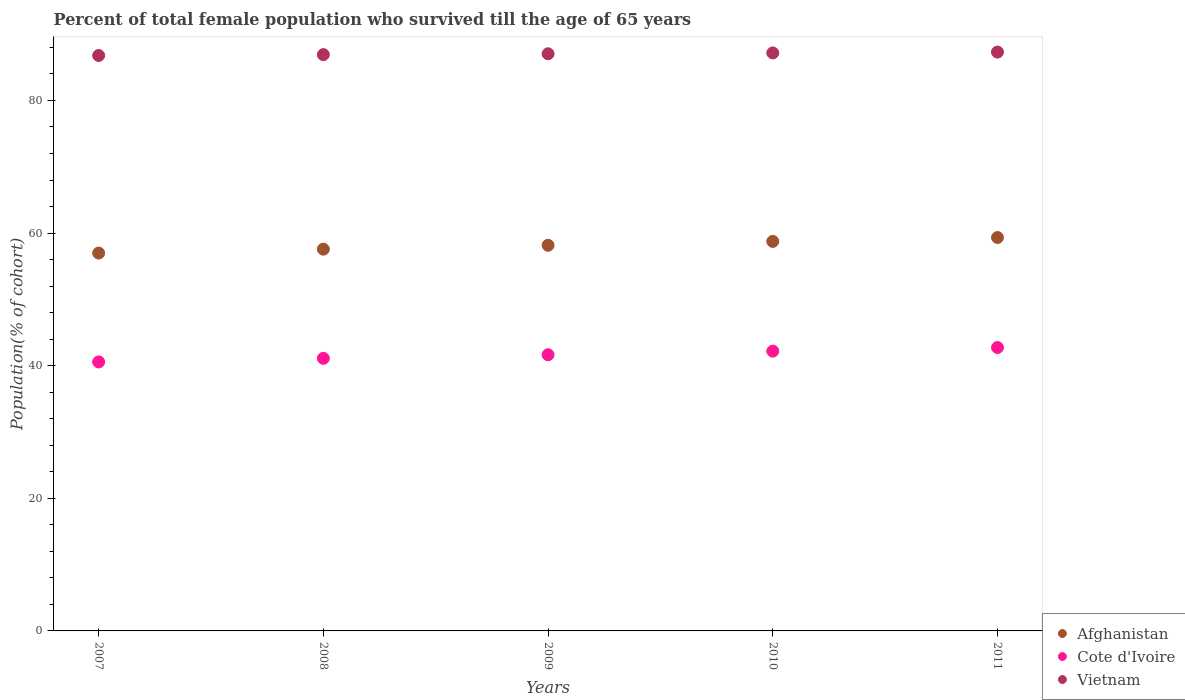How many different coloured dotlines are there?
Keep it short and to the point. 3. What is the percentage of total female population who survived till the age of 65 years in Afghanistan in 2008?
Make the answer very short. 57.57. Across all years, what is the maximum percentage of total female population who survived till the age of 65 years in Cote d'Ivoire?
Your response must be concise. 42.74. Across all years, what is the minimum percentage of total female population who survived till the age of 65 years in Vietnam?
Provide a short and direct response. 86.78. In which year was the percentage of total female population who survived till the age of 65 years in Cote d'Ivoire minimum?
Your response must be concise. 2007. What is the total percentage of total female population who survived till the age of 65 years in Vietnam in the graph?
Your answer should be compact. 435.21. What is the difference between the percentage of total female population who survived till the age of 65 years in Cote d'Ivoire in 2007 and that in 2008?
Ensure brevity in your answer.  -0.54. What is the difference between the percentage of total female population who survived till the age of 65 years in Vietnam in 2010 and the percentage of total female population who survived till the age of 65 years in Afghanistan in 2009?
Ensure brevity in your answer.  29.01. What is the average percentage of total female population who survived till the age of 65 years in Afghanistan per year?
Offer a very short reply. 58.16. In the year 2007, what is the difference between the percentage of total female population who survived till the age of 65 years in Afghanistan and percentage of total female population who survived till the age of 65 years in Cote d'Ivoire?
Keep it short and to the point. 16.42. What is the ratio of the percentage of total female population who survived till the age of 65 years in Afghanistan in 2009 to that in 2010?
Your answer should be compact. 0.99. Is the difference between the percentage of total female population who survived till the age of 65 years in Afghanistan in 2007 and 2011 greater than the difference between the percentage of total female population who survived till the age of 65 years in Cote d'Ivoire in 2007 and 2011?
Offer a very short reply. No. What is the difference between the highest and the second highest percentage of total female population who survived till the age of 65 years in Vietnam?
Offer a very short reply. 0.13. What is the difference between the highest and the lowest percentage of total female population who survived till the age of 65 years in Cote d'Ivoire?
Give a very brief answer. 2.17. Does the percentage of total female population who survived till the age of 65 years in Vietnam monotonically increase over the years?
Your response must be concise. Yes. Is the percentage of total female population who survived till the age of 65 years in Afghanistan strictly greater than the percentage of total female population who survived till the age of 65 years in Cote d'Ivoire over the years?
Keep it short and to the point. Yes. Is the percentage of total female population who survived till the age of 65 years in Afghanistan strictly less than the percentage of total female population who survived till the age of 65 years in Cote d'Ivoire over the years?
Keep it short and to the point. No. How many dotlines are there?
Offer a terse response. 3. What is the difference between two consecutive major ticks on the Y-axis?
Give a very brief answer. 20. Does the graph contain any zero values?
Your answer should be compact. No. Does the graph contain grids?
Provide a succinct answer. No. Where does the legend appear in the graph?
Your answer should be very brief. Bottom right. What is the title of the graph?
Make the answer very short. Percent of total female population who survived till the age of 65 years. What is the label or title of the X-axis?
Your response must be concise. Years. What is the label or title of the Y-axis?
Your response must be concise. Population(% of cohort). What is the Population(% of cohort) of Afghanistan in 2007?
Make the answer very short. 56.99. What is the Population(% of cohort) in Cote d'Ivoire in 2007?
Provide a short and direct response. 40.57. What is the Population(% of cohort) of Vietnam in 2007?
Your answer should be very brief. 86.78. What is the Population(% of cohort) of Afghanistan in 2008?
Your answer should be compact. 57.57. What is the Population(% of cohort) in Cote d'Ivoire in 2008?
Offer a terse response. 41.11. What is the Population(% of cohort) in Vietnam in 2008?
Ensure brevity in your answer.  86.91. What is the Population(% of cohort) of Afghanistan in 2009?
Provide a succinct answer. 58.16. What is the Population(% of cohort) of Cote d'Ivoire in 2009?
Provide a succinct answer. 41.65. What is the Population(% of cohort) in Vietnam in 2009?
Ensure brevity in your answer.  87.04. What is the Population(% of cohort) in Afghanistan in 2010?
Your answer should be very brief. 58.74. What is the Population(% of cohort) of Cote d'Ivoire in 2010?
Provide a short and direct response. 42.2. What is the Population(% of cohort) of Vietnam in 2010?
Your response must be concise. 87.17. What is the Population(% of cohort) in Afghanistan in 2011?
Your answer should be compact. 59.33. What is the Population(% of cohort) in Cote d'Ivoire in 2011?
Provide a short and direct response. 42.74. What is the Population(% of cohort) of Vietnam in 2011?
Make the answer very short. 87.3. Across all years, what is the maximum Population(% of cohort) in Afghanistan?
Offer a very short reply. 59.33. Across all years, what is the maximum Population(% of cohort) of Cote d'Ivoire?
Make the answer very short. 42.74. Across all years, what is the maximum Population(% of cohort) of Vietnam?
Keep it short and to the point. 87.3. Across all years, what is the minimum Population(% of cohort) in Afghanistan?
Your response must be concise. 56.99. Across all years, what is the minimum Population(% of cohort) in Cote d'Ivoire?
Give a very brief answer. 40.57. Across all years, what is the minimum Population(% of cohort) of Vietnam?
Provide a short and direct response. 86.78. What is the total Population(% of cohort) in Afghanistan in the graph?
Your response must be concise. 290.8. What is the total Population(% of cohort) in Cote d'Ivoire in the graph?
Offer a terse response. 208.26. What is the total Population(% of cohort) in Vietnam in the graph?
Offer a very short reply. 435.21. What is the difference between the Population(% of cohort) of Afghanistan in 2007 and that in 2008?
Ensure brevity in your answer.  -0.59. What is the difference between the Population(% of cohort) in Cote d'Ivoire in 2007 and that in 2008?
Provide a short and direct response. -0.54. What is the difference between the Population(% of cohort) of Vietnam in 2007 and that in 2008?
Your answer should be very brief. -0.13. What is the difference between the Population(% of cohort) of Afghanistan in 2007 and that in 2009?
Your answer should be compact. -1.17. What is the difference between the Population(% of cohort) of Cote d'Ivoire in 2007 and that in 2009?
Provide a short and direct response. -1.08. What is the difference between the Population(% of cohort) of Vietnam in 2007 and that in 2009?
Give a very brief answer. -0.26. What is the difference between the Population(% of cohort) of Afghanistan in 2007 and that in 2010?
Keep it short and to the point. -1.76. What is the difference between the Population(% of cohort) in Cote d'Ivoire in 2007 and that in 2010?
Your response must be concise. -1.63. What is the difference between the Population(% of cohort) in Vietnam in 2007 and that in 2010?
Provide a succinct answer. -0.39. What is the difference between the Population(% of cohort) in Afghanistan in 2007 and that in 2011?
Offer a terse response. -2.34. What is the difference between the Population(% of cohort) in Cote d'Ivoire in 2007 and that in 2011?
Offer a terse response. -2.17. What is the difference between the Population(% of cohort) of Vietnam in 2007 and that in 2011?
Your answer should be very brief. -0.52. What is the difference between the Population(% of cohort) of Afghanistan in 2008 and that in 2009?
Ensure brevity in your answer.  -0.59. What is the difference between the Population(% of cohort) of Cote d'Ivoire in 2008 and that in 2009?
Ensure brevity in your answer.  -0.54. What is the difference between the Population(% of cohort) in Vietnam in 2008 and that in 2009?
Provide a short and direct response. -0.13. What is the difference between the Population(% of cohort) in Afghanistan in 2008 and that in 2010?
Ensure brevity in your answer.  -1.17. What is the difference between the Population(% of cohort) of Cote d'Ivoire in 2008 and that in 2010?
Provide a succinct answer. -1.08. What is the difference between the Population(% of cohort) in Vietnam in 2008 and that in 2010?
Ensure brevity in your answer.  -0.26. What is the difference between the Population(% of cohort) of Afghanistan in 2008 and that in 2011?
Provide a succinct answer. -1.76. What is the difference between the Population(% of cohort) in Cote d'Ivoire in 2008 and that in 2011?
Provide a succinct answer. -1.63. What is the difference between the Population(% of cohort) in Vietnam in 2008 and that in 2011?
Offer a terse response. -0.39. What is the difference between the Population(% of cohort) in Afghanistan in 2009 and that in 2010?
Make the answer very short. -0.59. What is the difference between the Population(% of cohort) in Cote d'Ivoire in 2009 and that in 2010?
Give a very brief answer. -0.54. What is the difference between the Population(% of cohort) of Vietnam in 2009 and that in 2010?
Ensure brevity in your answer.  -0.13. What is the difference between the Population(% of cohort) in Afghanistan in 2009 and that in 2011?
Your answer should be very brief. -1.17. What is the difference between the Population(% of cohort) of Cote d'Ivoire in 2009 and that in 2011?
Offer a terse response. -1.08. What is the difference between the Population(% of cohort) of Vietnam in 2009 and that in 2011?
Make the answer very short. -0.26. What is the difference between the Population(% of cohort) of Afghanistan in 2010 and that in 2011?
Offer a terse response. -0.59. What is the difference between the Population(% of cohort) in Cote d'Ivoire in 2010 and that in 2011?
Provide a succinct answer. -0.54. What is the difference between the Population(% of cohort) of Vietnam in 2010 and that in 2011?
Provide a short and direct response. -0.13. What is the difference between the Population(% of cohort) of Afghanistan in 2007 and the Population(% of cohort) of Cote d'Ivoire in 2008?
Make the answer very short. 15.88. What is the difference between the Population(% of cohort) in Afghanistan in 2007 and the Population(% of cohort) in Vietnam in 2008?
Offer a terse response. -29.92. What is the difference between the Population(% of cohort) in Cote d'Ivoire in 2007 and the Population(% of cohort) in Vietnam in 2008?
Make the answer very short. -46.34. What is the difference between the Population(% of cohort) in Afghanistan in 2007 and the Population(% of cohort) in Cote d'Ivoire in 2009?
Keep it short and to the point. 15.34. What is the difference between the Population(% of cohort) of Afghanistan in 2007 and the Population(% of cohort) of Vietnam in 2009?
Ensure brevity in your answer.  -30.05. What is the difference between the Population(% of cohort) in Cote d'Ivoire in 2007 and the Population(% of cohort) in Vietnam in 2009?
Offer a very short reply. -46.47. What is the difference between the Population(% of cohort) of Afghanistan in 2007 and the Population(% of cohort) of Cote d'Ivoire in 2010?
Provide a succinct answer. 14.79. What is the difference between the Population(% of cohort) of Afghanistan in 2007 and the Population(% of cohort) of Vietnam in 2010?
Your answer should be compact. -30.18. What is the difference between the Population(% of cohort) of Cote d'Ivoire in 2007 and the Population(% of cohort) of Vietnam in 2010?
Your answer should be very brief. -46.6. What is the difference between the Population(% of cohort) of Afghanistan in 2007 and the Population(% of cohort) of Cote d'Ivoire in 2011?
Provide a succinct answer. 14.25. What is the difference between the Population(% of cohort) of Afghanistan in 2007 and the Population(% of cohort) of Vietnam in 2011?
Your response must be concise. -30.31. What is the difference between the Population(% of cohort) of Cote d'Ivoire in 2007 and the Population(% of cohort) of Vietnam in 2011?
Give a very brief answer. -46.73. What is the difference between the Population(% of cohort) in Afghanistan in 2008 and the Population(% of cohort) in Cote d'Ivoire in 2009?
Your response must be concise. 15.92. What is the difference between the Population(% of cohort) of Afghanistan in 2008 and the Population(% of cohort) of Vietnam in 2009?
Provide a short and direct response. -29.47. What is the difference between the Population(% of cohort) of Cote d'Ivoire in 2008 and the Population(% of cohort) of Vietnam in 2009?
Your response must be concise. -45.93. What is the difference between the Population(% of cohort) in Afghanistan in 2008 and the Population(% of cohort) in Cote d'Ivoire in 2010?
Ensure brevity in your answer.  15.38. What is the difference between the Population(% of cohort) in Afghanistan in 2008 and the Population(% of cohort) in Vietnam in 2010?
Offer a very short reply. -29.6. What is the difference between the Population(% of cohort) in Cote d'Ivoire in 2008 and the Population(% of cohort) in Vietnam in 2010?
Keep it short and to the point. -46.06. What is the difference between the Population(% of cohort) of Afghanistan in 2008 and the Population(% of cohort) of Cote d'Ivoire in 2011?
Provide a short and direct response. 14.84. What is the difference between the Population(% of cohort) of Afghanistan in 2008 and the Population(% of cohort) of Vietnam in 2011?
Your answer should be compact. -29.73. What is the difference between the Population(% of cohort) in Cote d'Ivoire in 2008 and the Population(% of cohort) in Vietnam in 2011?
Provide a short and direct response. -46.19. What is the difference between the Population(% of cohort) in Afghanistan in 2009 and the Population(% of cohort) in Cote d'Ivoire in 2010?
Offer a terse response. 15.96. What is the difference between the Population(% of cohort) of Afghanistan in 2009 and the Population(% of cohort) of Vietnam in 2010?
Offer a very short reply. -29.01. What is the difference between the Population(% of cohort) of Cote d'Ivoire in 2009 and the Population(% of cohort) of Vietnam in 2010?
Make the answer very short. -45.52. What is the difference between the Population(% of cohort) of Afghanistan in 2009 and the Population(% of cohort) of Cote d'Ivoire in 2011?
Keep it short and to the point. 15.42. What is the difference between the Population(% of cohort) of Afghanistan in 2009 and the Population(% of cohort) of Vietnam in 2011?
Provide a short and direct response. -29.14. What is the difference between the Population(% of cohort) in Cote d'Ivoire in 2009 and the Population(% of cohort) in Vietnam in 2011?
Ensure brevity in your answer.  -45.65. What is the difference between the Population(% of cohort) of Afghanistan in 2010 and the Population(% of cohort) of Cote d'Ivoire in 2011?
Make the answer very short. 16.01. What is the difference between the Population(% of cohort) in Afghanistan in 2010 and the Population(% of cohort) in Vietnam in 2011?
Offer a very short reply. -28.55. What is the difference between the Population(% of cohort) of Cote d'Ivoire in 2010 and the Population(% of cohort) of Vietnam in 2011?
Give a very brief answer. -45.1. What is the average Population(% of cohort) of Afghanistan per year?
Your answer should be very brief. 58.16. What is the average Population(% of cohort) in Cote d'Ivoire per year?
Keep it short and to the point. 41.65. What is the average Population(% of cohort) in Vietnam per year?
Your response must be concise. 87.04. In the year 2007, what is the difference between the Population(% of cohort) of Afghanistan and Population(% of cohort) of Cote d'Ivoire?
Ensure brevity in your answer.  16.42. In the year 2007, what is the difference between the Population(% of cohort) of Afghanistan and Population(% of cohort) of Vietnam?
Offer a very short reply. -29.79. In the year 2007, what is the difference between the Population(% of cohort) of Cote d'Ivoire and Population(% of cohort) of Vietnam?
Ensure brevity in your answer.  -46.22. In the year 2008, what is the difference between the Population(% of cohort) in Afghanistan and Population(% of cohort) in Cote d'Ivoire?
Make the answer very short. 16.46. In the year 2008, what is the difference between the Population(% of cohort) in Afghanistan and Population(% of cohort) in Vietnam?
Your answer should be compact. -29.34. In the year 2008, what is the difference between the Population(% of cohort) in Cote d'Ivoire and Population(% of cohort) in Vietnam?
Give a very brief answer. -45.8. In the year 2009, what is the difference between the Population(% of cohort) in Afghanistan and Population(% of cohort) in Cote d'Ivoire?
Your answer should be compact. 16.51. In the year 2009, what is the difference between the Population(% of cohort) in Afghanistan and Population(% of cohort) in Vietnam?
Make the answer very short. -28.88. In the year 2009, what is the difference between the Population(% of cohort) of Cote d'Ivoire and Population(% of cohort) of Vietnam?
Your answer should be very brief. -45.39. In the year 2010, what is the difference between the Population(% of cohort) in Afghanistan and Population(% of cohort) in Cote d'Ivoire?
Ensure brevity in your answer.  16.55. In the year 2010, what is the difference between the Population(% of cohort) in Afghanistan and Population(% of cohort) in Vietnam?
Ensure brevity in your answer.  -28.43. In the year 2010, what is the difference between the Population(% of cohort) in Cote d'Ivoire and Population(% of cohort) in Vietnam?
Your answer should be compact. -44.98. In the year 2011, what is the difference between the Population(% of cohort) in Afghanistan and Population(% of cohort) in Cote d'Ivoire?
Your answer should be compact. 16.59. In the year 2011, what is the difference between the Population(% of cohort) of Afghanistan and Population(% of cohort) of Vietnam?
Give a very brief answer. -27.97. In the year 2011, what is the difference between the Population(% of cohort) in Cote d'Ivoire and Population(% of cohort) in Vietnam?
Offer a terse response. -44.56. What is the ratio of the Population(% of cohort) in Vietnam in 2007 to that in 2008?
Provide a short and direct response. 1. What is the ratio of the Population(% of cohort) in Afghanistan in 2007 to that in 2009?
Your answer should be compact. 0.98. What is the ratio of the Population(% of cohort) of Afghanistan in 2007 to that in 2010?
Offer a very short reply. 0.97. What is the ratio of the Population(% of cohort) of Cote d'Ivoire in 2007 to that in 2010?
Provide a succinct answer. 0.96. What is the ratio of the Population(% of cohort) in Afghanistan in 2007 to that in 2011?
Make the answer very short. 0.96. What is the ratio of the Population(% of cohort) of Cote d'Ivoire in 2007 to that in 2011?
Make the answer very short. 0.95. What is the ratio of the Population(% of cohort) in Vietnam in 2007 to that in 2011?
Keep it short and to the point. 0.99. What is the ratio of the Population(% of cohort) in Afghanistan in 2008 to that in 2009?
Your answer should be very brief. 0.99. What is the ratio of the Population(% of cohort) in Cote d'Ivoire in 2008 to that in 2009?
Provide a short and direct response. 0.99. What is the ratio of the Population(% of cohort) in Afghanistan in 2008 to that in 2010?
Make the answer very short. 0.98. What is the ratio of the Population(% of cohort) of Cote d'Ivoire in 2008 to that in 2010?
Offer a terse response. 0.97. What is the ratio of the Population(% of cohort) of Vietnam in 2008 to that in 2010?
Provide a short and direct response. 1. What is the ratio of the Population(% of cohort) in Afghanistan in 2008 to that in 2011?
Ensure brevity in your answer.  0.97. What is the ratio of the Population(% of cohort) of Cote d'Ivoire in 2008 to that in 2011?
Provide a short and direct response. 0.96. What is the ratio of the Population(% of cohort) of Vietnam in 2008 to that in 2011?
Your response must be concise. 1. What is the ratio of the Population(% of cohort) in Cote d'Ivoire in 2009 to that in 2010?
Make the answer very short. 0.99. What is the ratio of the Population(% of cohort) in Vietnam in 2009 to that in 2010?
Your response must be concise. 1. What is the ratio of the Population(% of cohort) in Afghanistan in 2009 to that in 2011?
Make the answer very short. 0.98. What is the ratio of the Population(% of cohort) in Cote d'Ivoire in 2009 to that in 2011?
Your response must be concise. 0.97. What is the ratio of the Population(% of cohort) of Vietnam in 2009 to that in 2011?
Your answer should be compact. 1. What is the ratio of the Population(% of cohort) in Cote d'Ivoire in 2010 to that in 2011?
Provide a succinct answer. 0.99. What is the difference between the highest and the second highest Population(% of cohort) of Afghanistan?
Offer a very short reply. 0.59. What is the difference between the highest and the second highest Population(% of cohort) of Cote d'Ivoire?
Your answer should be compact. 0.54. What is the difference between the highest and the second highest Population(% of cohort) in Vietnam?
Provide a short and direct response. 0.13. What is the difference between the highest and the lowest Population(% of cohort) of Afghanistan?
Give a very brief answer. 2.34. What is the difference between the highest and the lowest Population(% of cohort) in Cote d'Ivoire?
Your answer should be very brief. 2.17. What is the difference between the highest and the lowest Population(% of cohort) in Vietnam?
Provide a succinct answer. 0.52. 